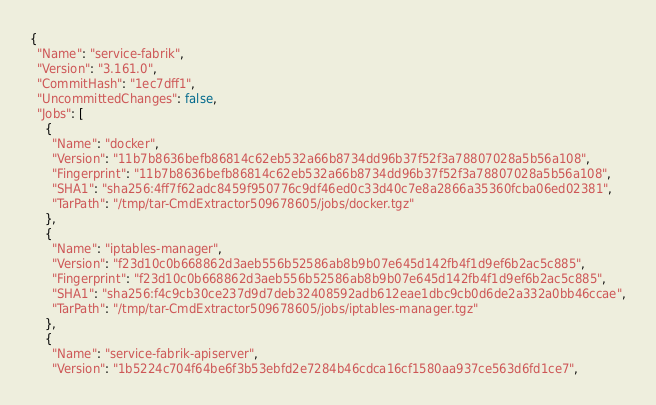<code> <loc_0><loc_0><loc_500><loc_500><_YAML_>{
  "Name": "service-fabrik",
  "Version": "3.161.0",
  "CommitHash": "1ec7dff1",
  "UncommittedChanges": false,
  "Jobs": [
    {
      "Name": "docker",
      "Version": "11b7b8636befb86814c62eb532a66b8734dd96b37f52f3a78807028a5b56a108",
      "Fingerprint": "11b7b8636befb86814c62eb532a66b8734dd96b37f52f3a78807028a5b56a108",
      "SHA1": "sha256:4ff7f62adc8459f950776c9df46ed0c33d40c7e8a2866a35360fcba06ed02381",
      "TarPath": "/tmp/tar-CmdExtractor509678605/jobs/docker.tgz"
    },
    {
      "Name": "iptables-manager",
      "Version": "f23d10c0b668862d3aeb556b52586ab8b9b07e645d142fb4f1d9ef6b2ac5c885",
      "Fingerprint": "f23d10c0b668862d3aeb556b52586ab8b9b07e645d142fb4f1d9ef6b2ac5c885",
      "SHA1": "sha256:f4c9cb30ce237d9d7deb32408592adb612eae1dbc9cb0d6de2a332a0bb46ccae",
      "TarPath": "/tmp/tar-CmdExtractor509678605/jobs/iptables-manager.tgz"
    },
    {
      "Name": "service-fabrik-apiserver",
      "Version": "1b5224c704f64be6f3b53ebfd2e7284b46cdca16cf1580aa937ce563d6fd1ce7",</code> 